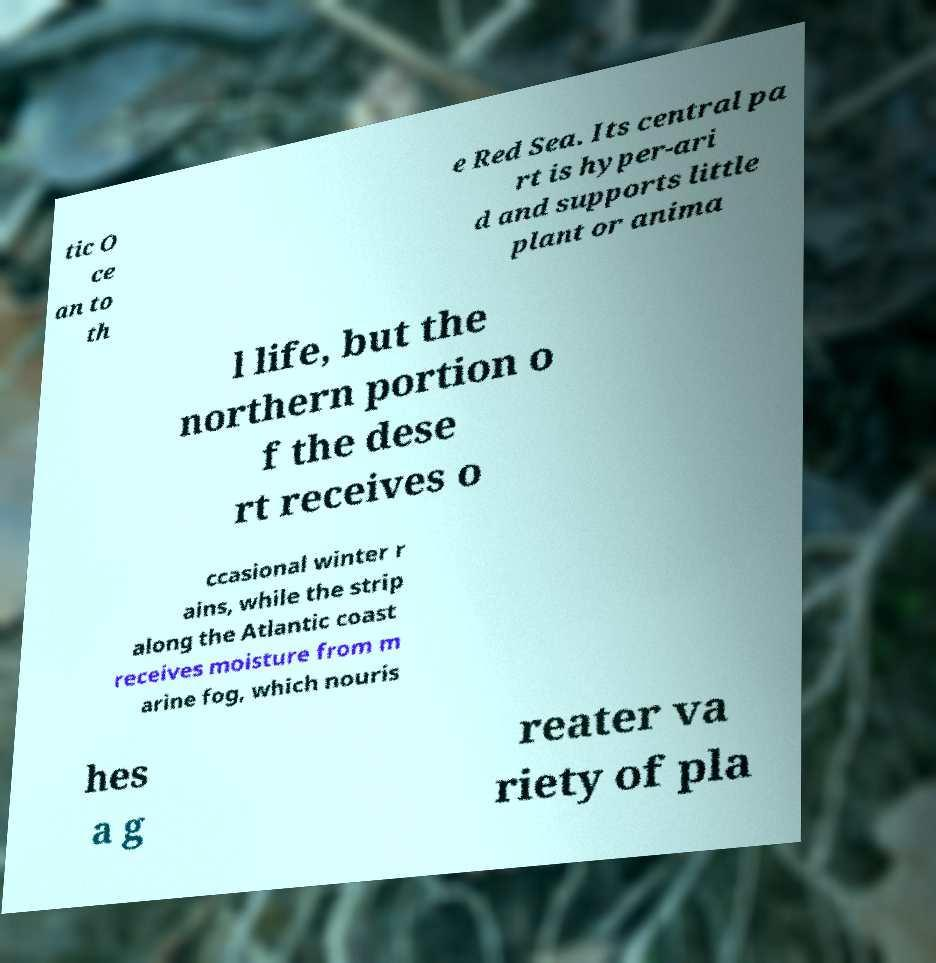What messages or text are displayed in this image? I need them in a readable, typed format. tic O ce an to th e Red Sea. Its central pa rt is hyper-ari d and supports little plant or anima l life, but the northern portion o f the dese rt receives o ccasional winter r ains, while the strip along the Atlantic coast receives moisture from m arine fog, which nouris hes a g reater va riety of pla 